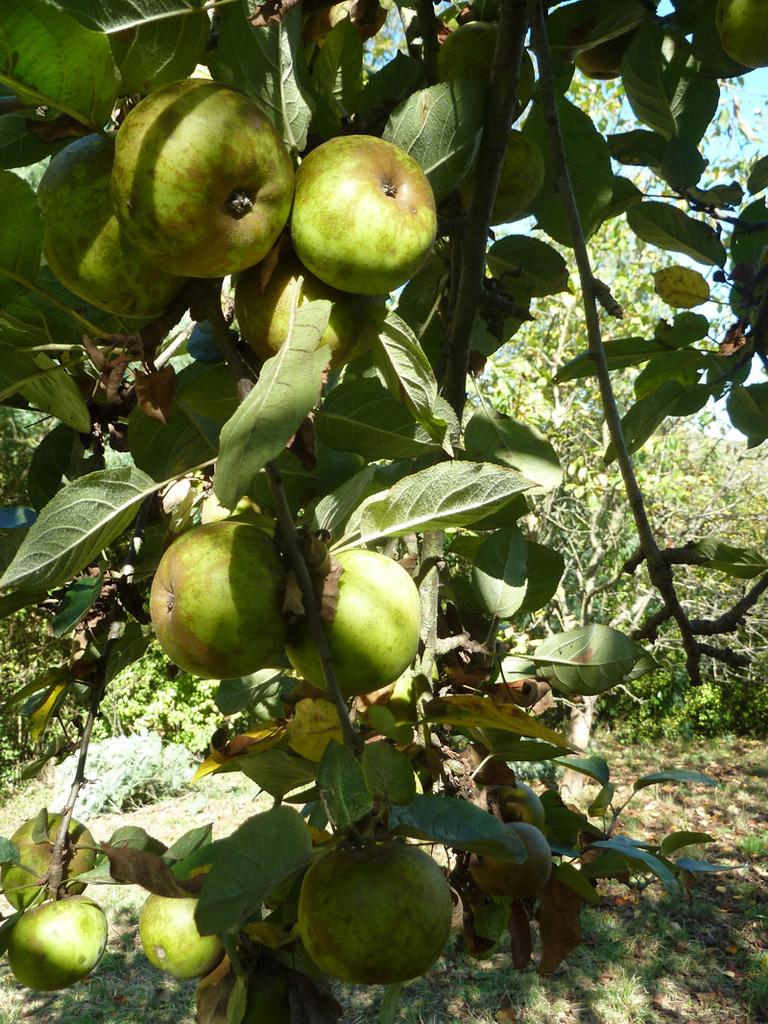What type of living organisms can be seen on the plant in the image? There are fruits on the plant in the image. What else can be seen in the image besides the plant with fruits? There are other plants visible in the background of the image. What can be seen in the sky in the background of the image? The sky is visible in the background of the image. What type of instrument is being played by the father in the image? There is no father or instrument present in the image. 